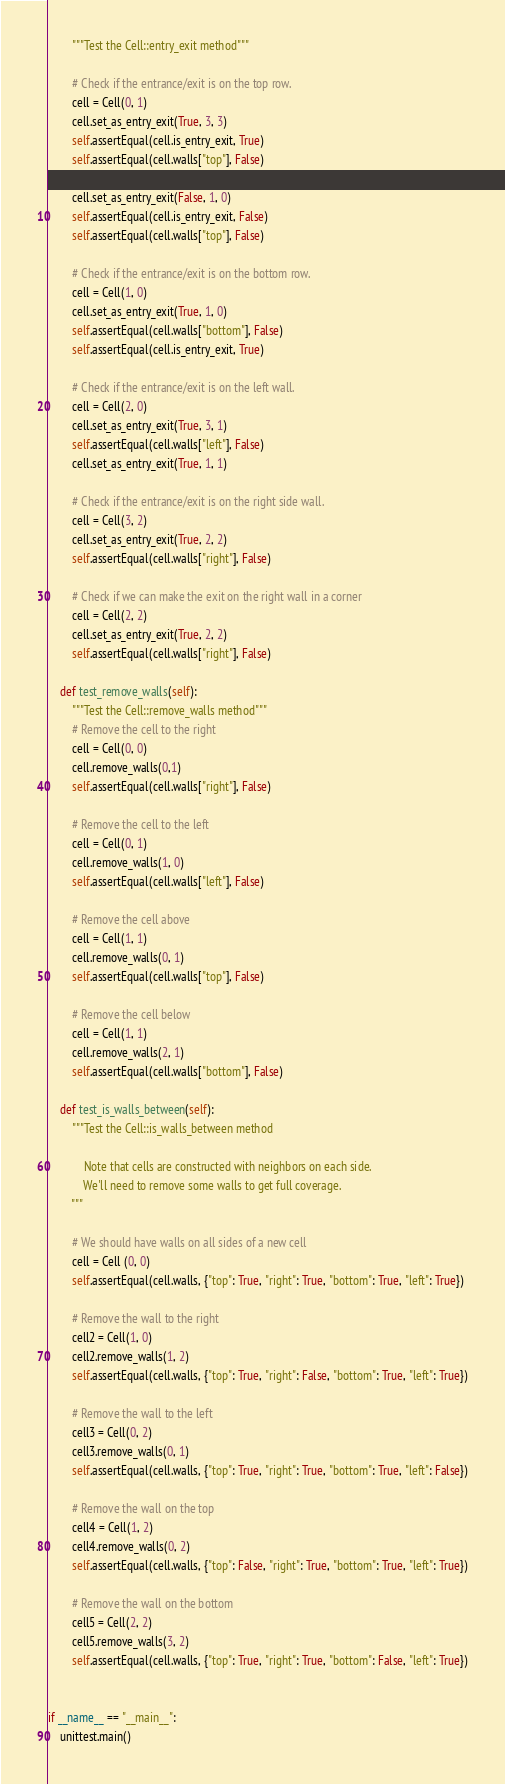<code> <loc_0><loc_0><loc_500><loc_500><_Python_>        """Test the Cell::entry_exit method"""

        # Check if the entrance/exit is on the top row.
        cell = Cell(0, 1)
        cell.set_as_entry_exit(True, 3, 3)
        self.assertEqual(cell.is_entry_exit, True)
        self.assertEqual(cell.walls["top"], False)

        cell.set_as_entry_exit(False, 1, 0)
        self.assertEqual(cell.is_entry_exit, False)
        self.assertEqual(cell.walls["top"], False)

        # Check if the entrance/exit is on the bottom row.
        cell = Cell(1, 0)
        cell.set_as_entry_exit(True, 1, 0)
        self.assertEqual(cell.walls["bottom"], False)
        self.assertEqual(cell.is_entry_exit, True)

        # Check if the entrance/exit is on the left wall.
        cell = Cell(2, 0)
        cell.set_as_entry_exit(True, 3, 1)
        self.assertEqual(cell.walls["left"], False)
        cell.set_as_entry_exit(True, 1, 1)

        # Check if the entrance/exit is on the right side wall.
        cell = Cell(3, 2)
        cell.set_as_entry_exit(True, 2, 2)
        self.assertEqual(cell.walls["right"], False)

        # Check if we can make the exit on the right wall in a corner
        cell = Cell(2, 2)
        cell.set_as_entry_exit(True, 2, 2)
        self.assertEqual(cell.walls["right"], False)

    def test_remove_walls(self):
        """Test the Cell::remove_walls method"""
        # Remove the cell to the right
        cell = Cell(0, 0)
        cell.remove_walls(0,1)
        self.assertEqual(cell.walls["right"], False)

        # Remove the cell to the left
        cell = Cell(0, 1)
        cell.remove_walls(1, 0)
        self.assertEqual(cell.walls["left"], False)

        # Remove the cell above
        cell = Cell(1, 1)
        cell.remove_walls(0, 1)
        self.assertEqual(cell.walls["top"], False)

        # Remove the cell below
        cell = Cell(1, 1)
        cell.remove_walls(2, 1)
        self.assertEqual(cell.walls["bottom"], False)

    def test_is_walls_between(self):
        """Test the Cell::is_walls_between method

            Note that cells are constructed with neighbors on each side.
            We'll need to remove some walls to get full coverage.
        """

        # We should have walls on all sides of a new cell
        cell = Cell (0, 0)
        self.assertEqual(cell.walls, {"top": True, "right": True, "bottom": True, "left": True})

        # Remove the wall to the right
        cell2 = Cell(1, 0)
        cell2.remove_walls(1, 2)
        self.assertEqual(cell.walls, {"top": True, "right": False, "bottom": True, "left": True})

        # Remove the wall to the left
        cell3 = Cell(0, 2)
        cell3.remove_walls(0, 1)
        self.assertEqual(cell.walls, {"top": True, "right": True, "bottom": True, "left": False})

        # Remove the wall on the top
        cell4 = Cell(1, 2)
        cell4.remove_walls(0, 2)
        self.assertEqual(cell.walls, {"top": False, "right": True, "bottom": True, "left": True})

        # Remove the wall on the bottom
        cell5 = Cell(2, 2)
        cell5.remove_walls(3, 2)
        self.assertEqual(cell.walls, {"top": True, "right": True, "bottom": False, "left": True})


if __name__ == "__main__":
    unittest.main()</code> 